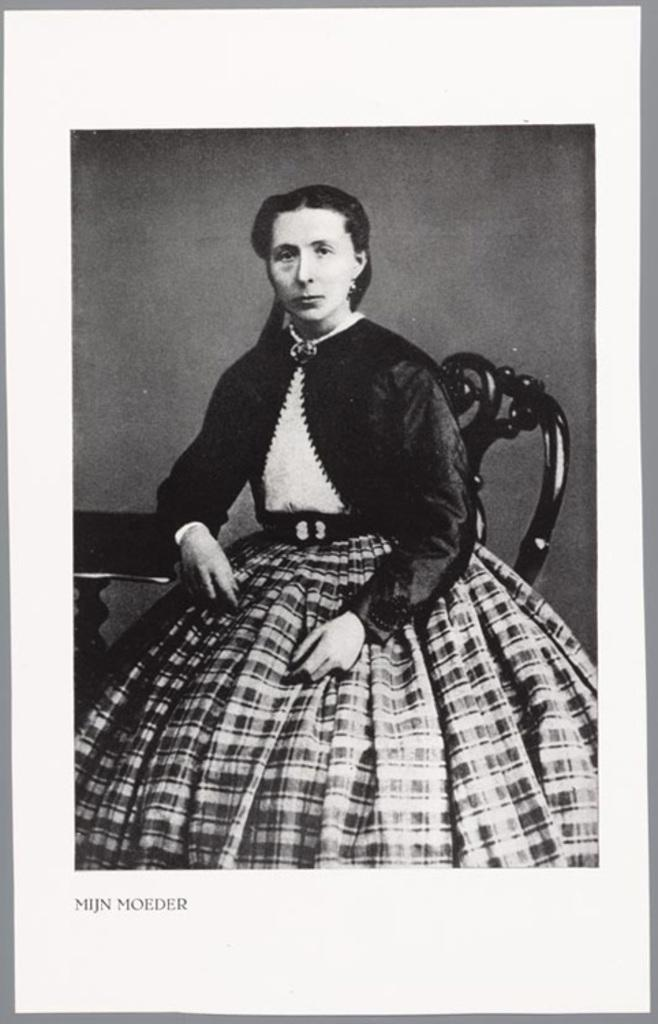What is the color scheme of the image? The image is black and white. What can be seen in the image besides the color scheme? There is a photo of a lady sitting on a chair in the image. Is there any text present in the image? Yes, there is text written at the bottom of the image. What else can be seen in the image? There is a stand in the image. Can you tell me how many hats the lady is wearing in the image? There is no hat visible in the image; the lady is not wearing any hats. Who is the owner of the stand in the image? The image does not provide information about the ownership of the stand, so it cannot be determined. 